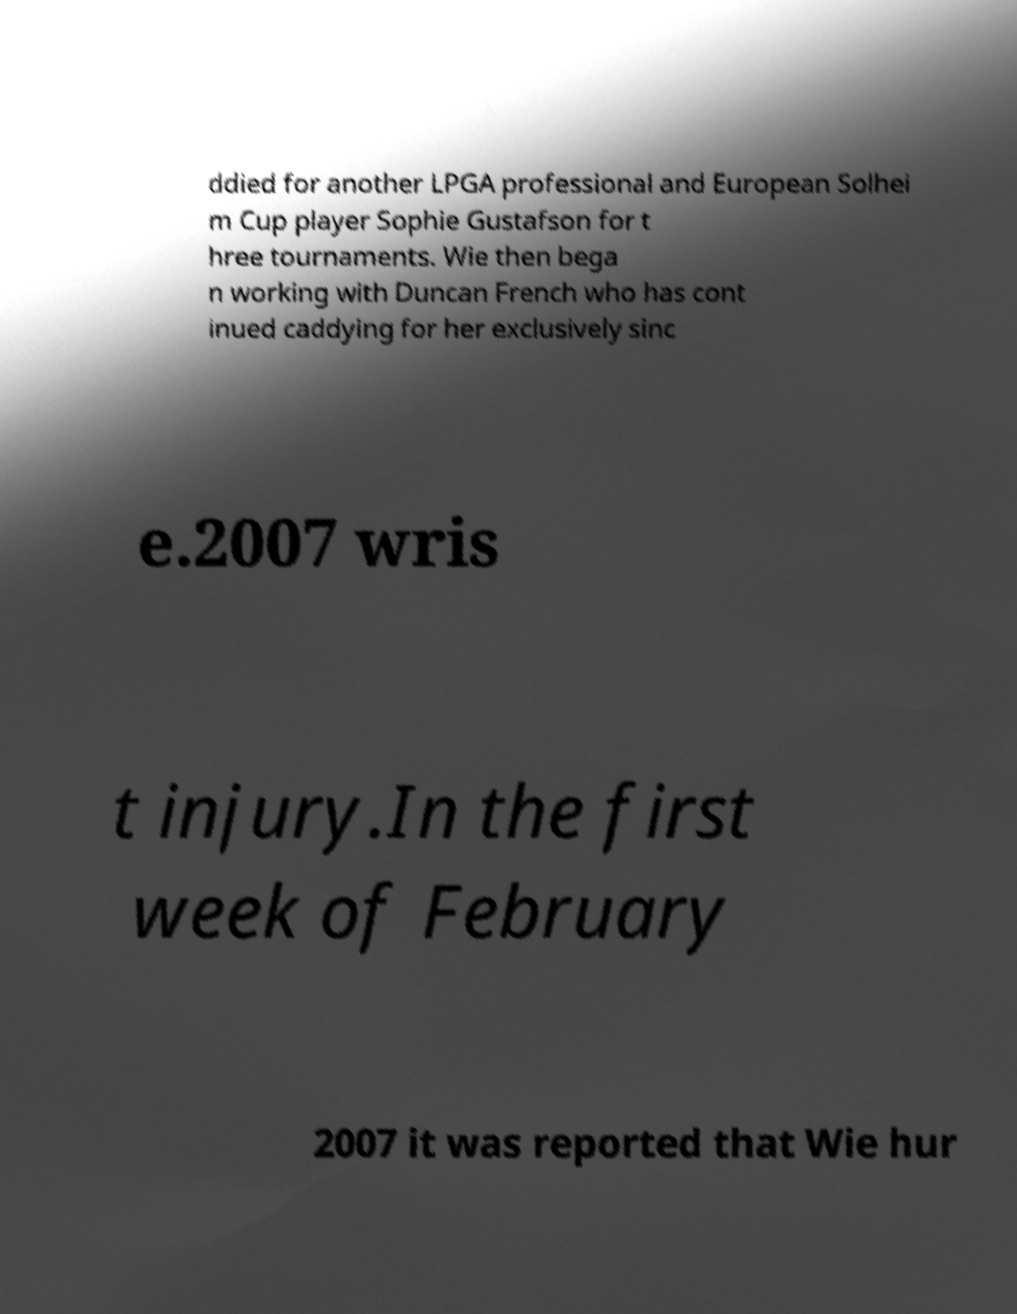There's text embedded in this image that I need extracted. Can you transcribe it verbatim? ddied for another LPGA professional and European Solhei m Cup player Sophie Gustafson for t hree tournaments. Wie then bega n working with Duncan French who has cont inued caddying for her exclusively sinc e.2007 wris t injury.In the first week of February 2007 it was reported that Wie hur 